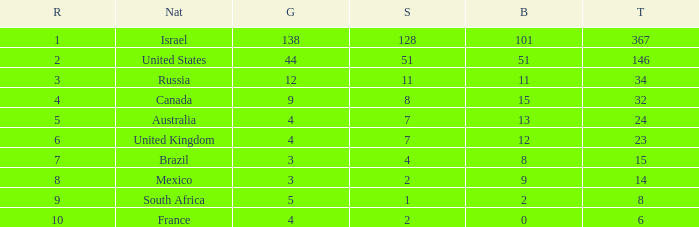What is the maximum number of silvers for a country with fewer than 12 golds and a total less than 8? 2.0. 